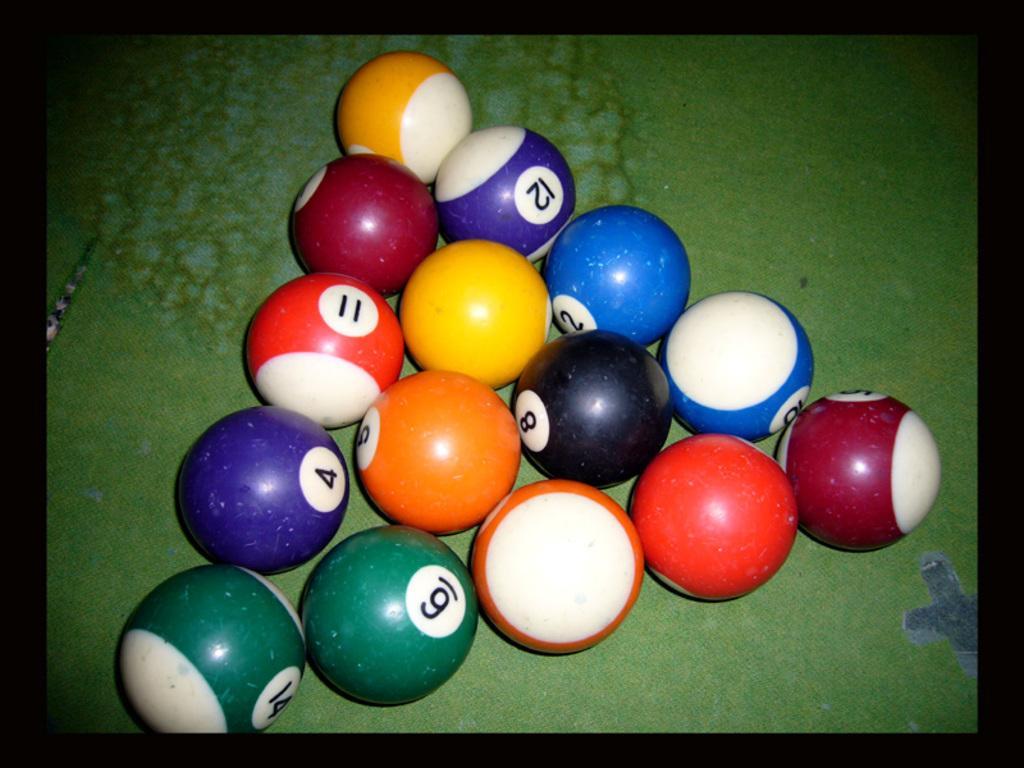How would you summarize this image in a sentence or two? In this image we can see balls are arranged in a triangular shape. 